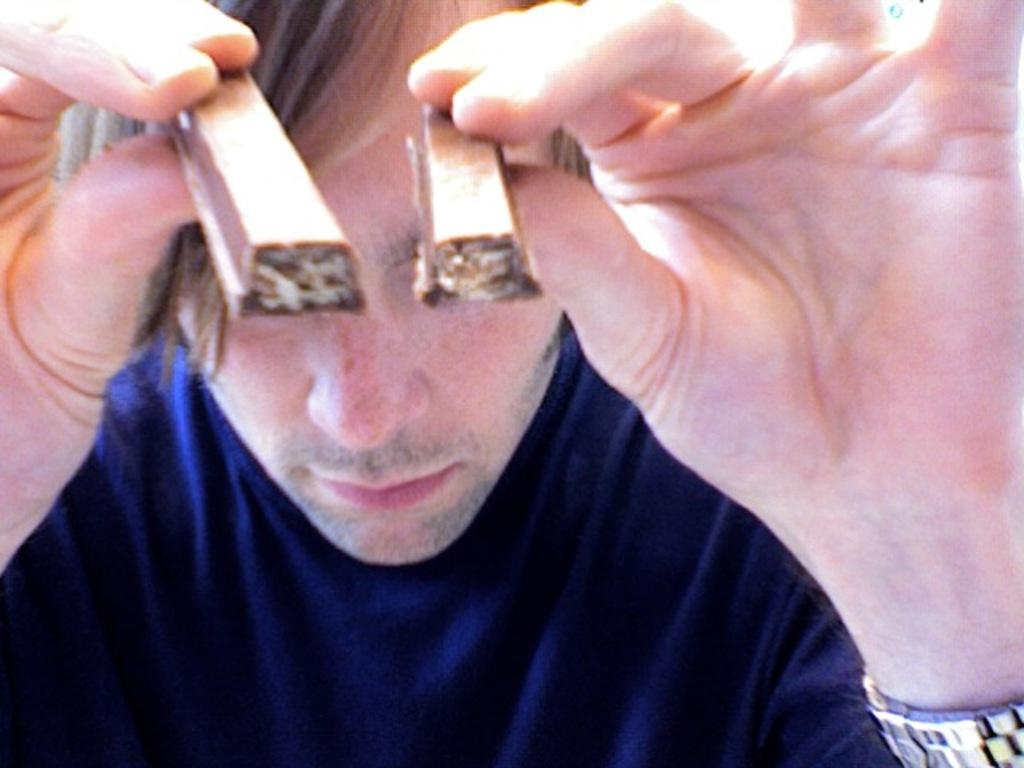Who is present in the image? There is a man in the picture. What is the man wearing? The man is wearing a T-shirt. What is the man holding in his hands? The man is holding chocolate pieces in his hands. What type of tooth can be seen in the man's hand in the image? There is no tooth present in the image; the man is holding chocolate pieces in his hands. 